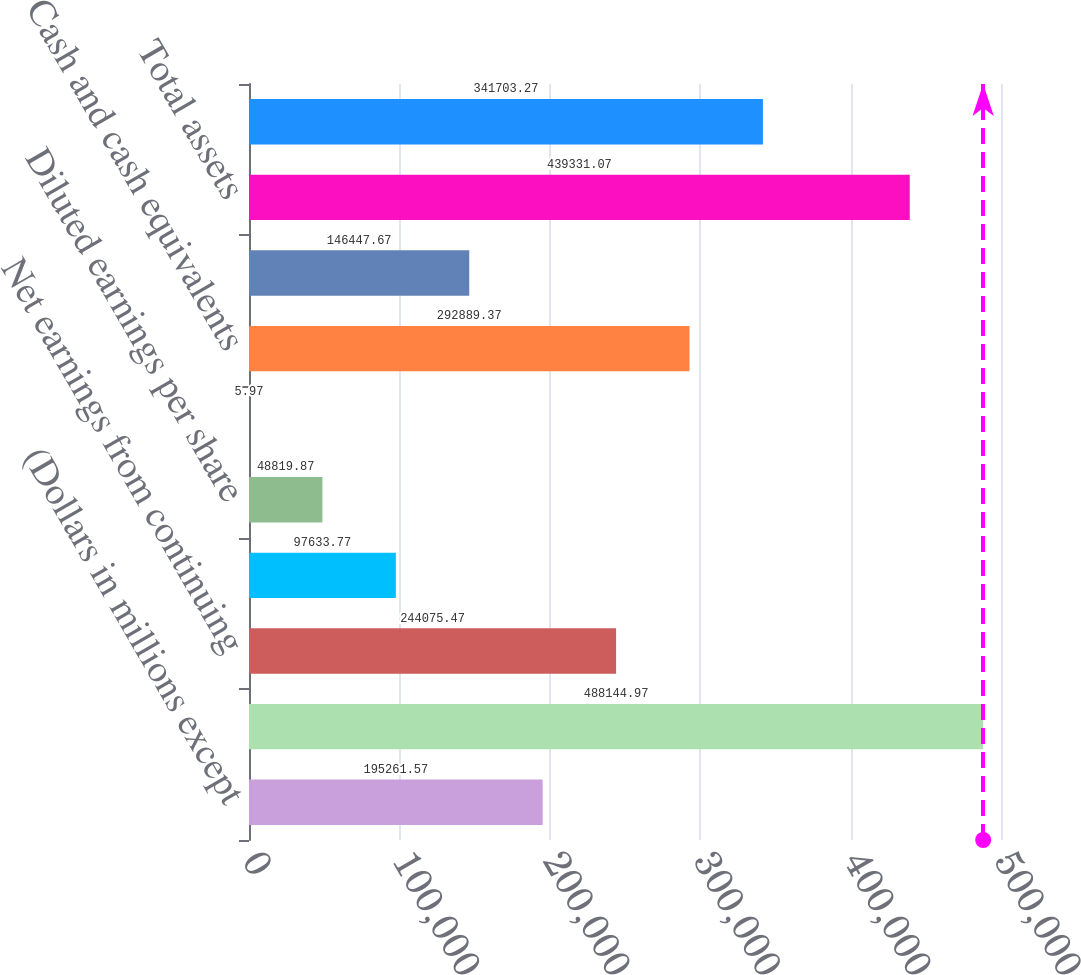Convert chart. <chart><loc_0><loc_0><loc_500><loc_500><bar_chart><fcel>(Dollars in millions except<fcel>Revenues<fcel>Net earnings from continuing<fcel>Basic earnings per share from<fcel>Diluted earnings per share<fcel>Dividends declared per share<fcel>Cash and cash equivalents<fcel>Short-term and other<fcel>Total assets<fcel>Total debt<nl><fcel>195262<fcel>488145<fcel>244075<fcel>97633.8<fcel>48819.9<fcel>5.97<fcel>292889<fcel>146448<fcel>439331<fcel>341703<nl></chart> 